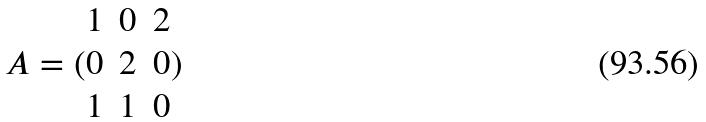<formula> <loc_0><loc_0><loc_500><loc_500>A = ( \begin{matrix} 1 & 0 & 2 \\ 0 & 2 & 0 \\ 1 & 1 & 0 \end{matrix} )</formula> 